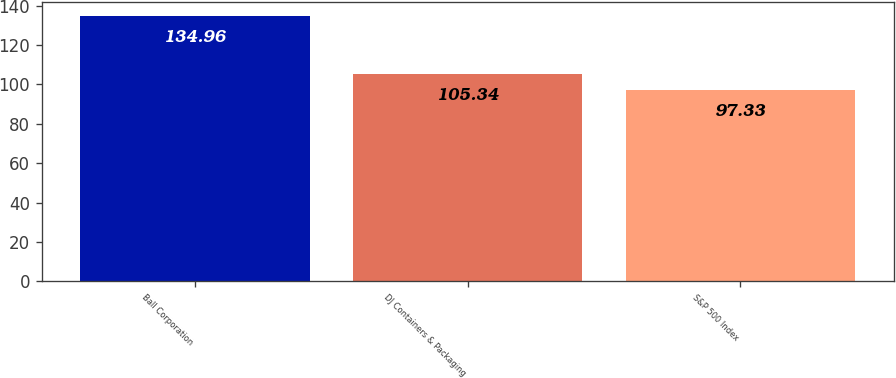<chart> <loc_0><loc_0><loc_500><loc_500><bar_chart><fcel>Ball Corporation<fcel>DJ Containers & Packaging<fcel>S&P 500 Index<nl><fcel>134.96<fcel>105.34<fcel>97.33<nl></chart> 